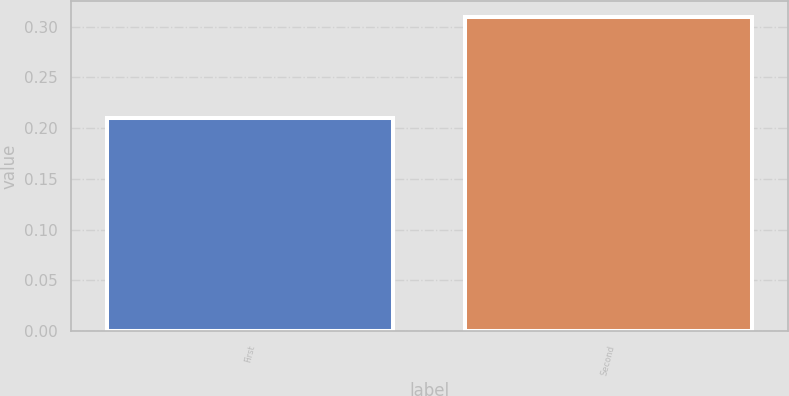Convert chart. <chart><loc_0><loc_0><loc_500><loc_500><bar_chart><fcel>First<fcel>Second<nl><fcel>0.21<fcel>0.31<nl></chart> 